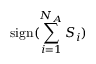Convert formula to latex. <formula><loc_0><loc_0><loc_500><loc_500>s i g n ( \sum _ { i = 1 } ^ { N _ { A } } S _ { i } )</formula> 